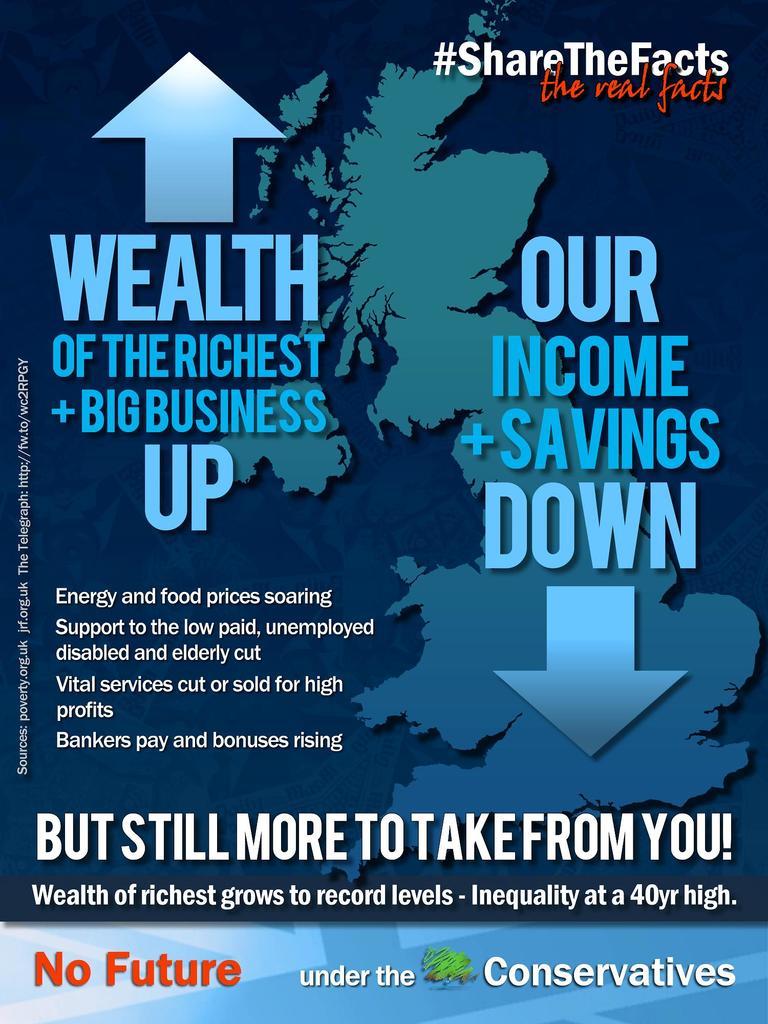What does this poster say is going down?
Make the answer very short. Our income + savings. What does the poster say is going up?
Offer a very short reply. Wealth. 